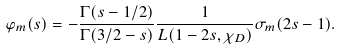Convert formula to latex. <formula><loc_0><loc_0><loc_500><loc_500>\varphi _ { m } ( s ) = - \frac { \Gamma ( s - 1 / 2 ) } { \Gamma ( 3 / 2 - s ) } \frac { 1 } { L ( 1 - 2 s , \chi _ { D } ) } \sigma _ { m } ( 2 s - 1 ) .</formula> 